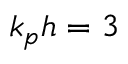<formula> <loc_0><loc_0><loc_500><loc_500>k _ { p } h = 3</formula> 